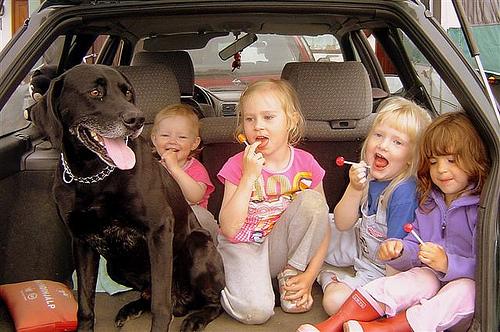Is the dog smaller than the children?
Concise answer only. No. Are the kids happy?
Answer briefly. Yes. How many kids are there?
Quick response, please. 4. 